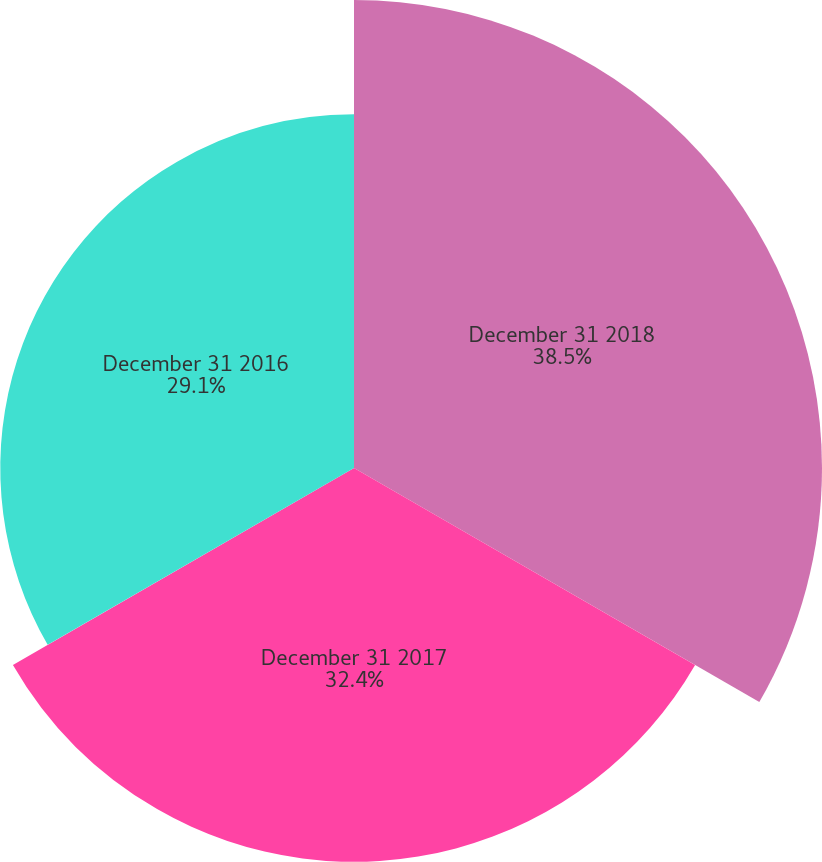Convert chart. <chart><loc_0><loc_0><loc_500><loc_500><pie_chart><fcel>December 31 2018<fcel>December 31 2017<fcel>December 31 2016<nl><fcel>38.5%<fcel>32.4%<fcel>29.1%<nl></chart> 